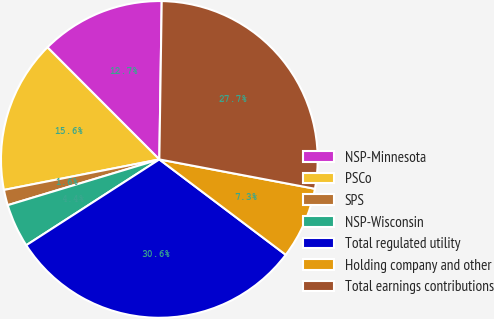Convert chart. <chart><loc_0><loc_0><loc_500><loc_500><pie_chart><fcel>NSP-Minnesota<fcel>PSCo<fcel>SPS<fcel>NSP-Wisconsin<fcel>Total regulated utility<fcel>Holding company and other<fcel>Total earnings contributions<nl><fcel>12.73%<fcel>15.6%<fcel>1.58%<fcel>4.45%<fcel>30.6%<fcel>7.32%<fcel>27.73%<nl></chart> 